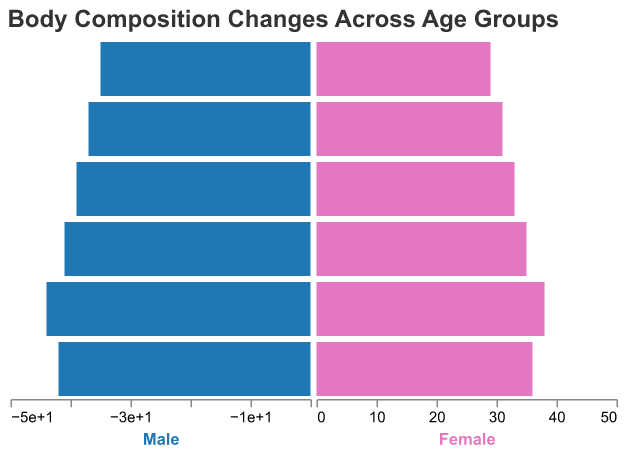what age group has the highest male muscle mass percentage? The figure shows muscle mass percentage by age group. The bar representing male muscle mass in the 25-34 age group extends furthest, indicating it has the highest value.
Answer: 25-34 what trend is noticeable in male muscle mass percentage as age increases? The bars for male muscle mass percentage decrease consistently from the left to the right of the figure as age increases, indicating a downward trend.
Answer: Decreasing trend how does the female body fat percentage in the 45-54 age group compare to the male body fat percentage in the same age group? In the 45-54 age group, the female body fat percentage bar reaches 26, while the male body fat percentage bar extends to -18. The female percentage is higher.
Answer: Female body fat percentage is higher what is the difference between the male muscle mass percentage and female muscle mass percentage in the 55-64 age group? The male muscle mass percentage for the 55-64 age group is 37, while the female muscle mass percentage is 31. The difference is calculated as 37 - 31.
Answer: 6 which age group has the highest female body fat percentage? The bars for female body fat percentage in the figure are highest for the 65+ age group, indicating this group has the highest female body fat percentage.
Answer: 65+ in the 35-44 age group, how much higher is the male muscle mass percentage compared to the female muscle mass percentage? For the 35-44 age group, the male muscle mass percentage is 41, and the female muscle mass percentage is 35. The difference is calculated as 41 - 35.
Answer: 6 which age group shows the smallest difference between male and female body fat percentages? For each age group, examine the lengths of the bars representing male and female body fat percentages. The smallest difference appears in the 25-34 age group where the male percentage is -14 and the female percentage is 22. The difference is 8.
Answer: 25-34 what overall pattern can be seen in male body fat percentage as age increases? Observing the bars for male body fat percentage, they increase progressively with age from -12 to -22, indicating an upward trend.
Answer: Increasing trend 